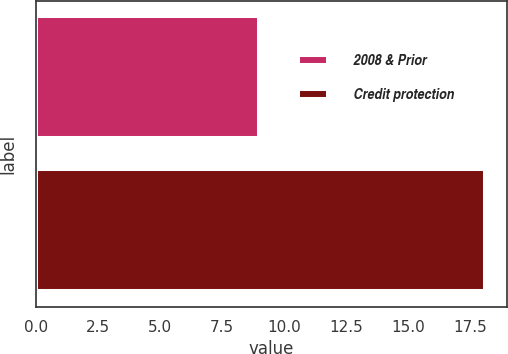Convert chart to OTSL. <chart><loc_0><loc_0><loc_500><loc_500><bar_chart><fcel>2008 & Prior<fcel>Credit protection<nl><fcel>9<fcel>18.1<nl></chart> 